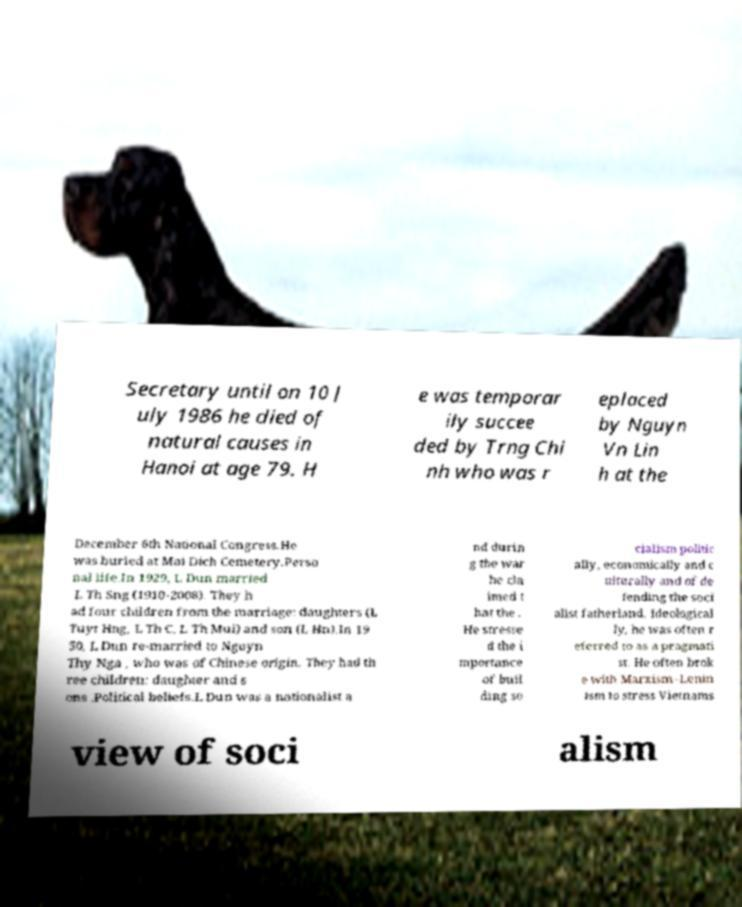I need the written content from this picture converted into text. Can you do that? Secretary until on 10 J uly 1986 he died of natural causes in Hanoi at age 79. H e was temporar ily succee ded by Trng Chi nh who was r eplaced by Nguyn Vn Lin h at the December 6th National Congress.He was buried at Mai Dich Cemetery.Perso nal life.In 1929, L Dun married L Th Sng (1910-2008). They h ad four children from the marriage: daughters (L Tuyt Hng, L Th C, L Th Mui) and son (L Hn).In 19 50, L Dun re-married to Nguyn Thy Nga , who was of Chinese origin. They had th ree children: daughter and s ons .Political beliefs.L Dun was a nationalist a nd durin g the war he cla imed t hat the . He stresse d the i mportance of buil ding so cialism politic ally, economically and c ulturally and of de fending the soci alist fatherland. Ideological ly, he was often r eferred to as a pragmati st. He often brok e with Marxism–Lenin ism to stress Vietnams view of soci alism 